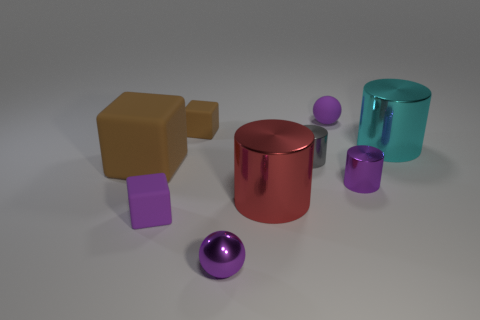Can you describe the lighting in the scene? The lighting in the scene appears to be soft and diffused, casting gentle shadows beneath the objects. This lighting helps to enhance the three-dimensional quality of the objects and doesn't create harsh reflections, which suggests an evenly lit environment, likely with an overhead light source that's not directly visible in the image. 